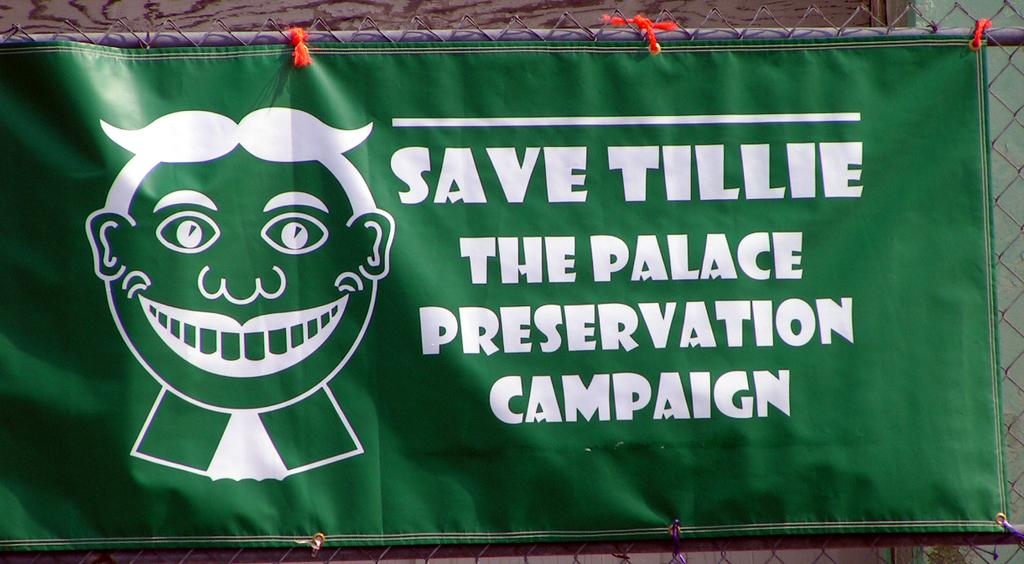<image>
Offer a succinct explanation of the picture presented. A banner that says Save Tillie The Palace Preservation Campaign. 